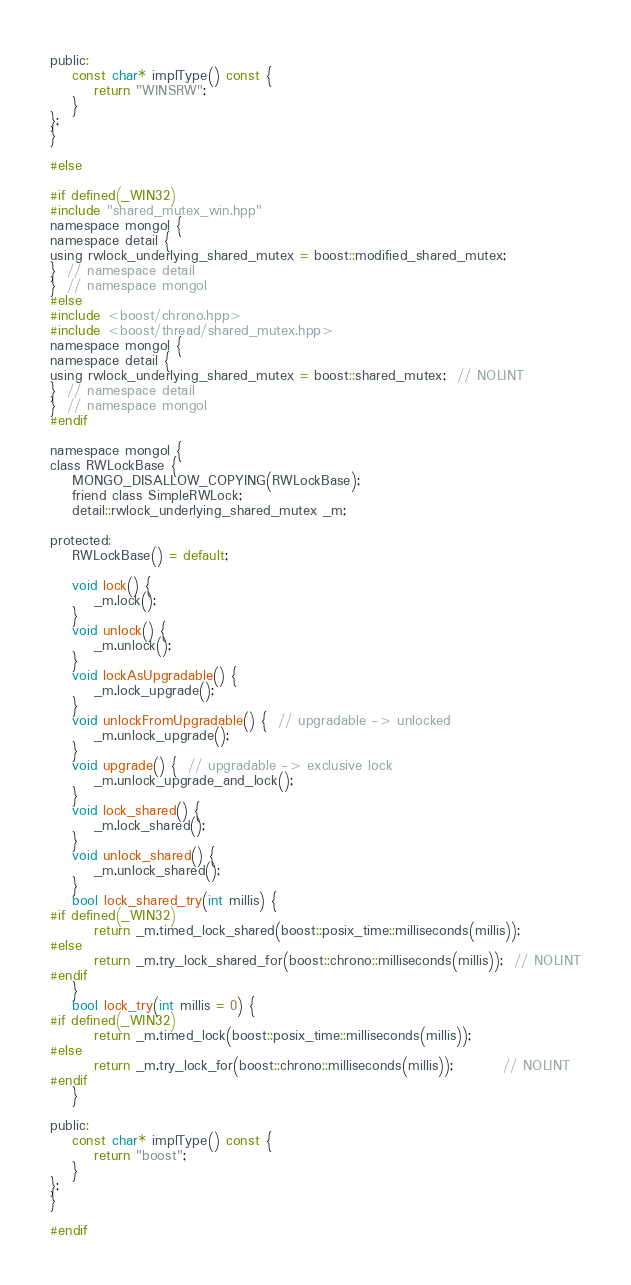<code> <loc_0><loc_0><loc_500><loc_500><_C_>public:
    const char* implType() const {
        return "WINSRW";
    }
};
}

#else

#if defined(_WIN32)
#include "shared_mutex_win.hpp"
namespace mongol {
namespace detail {
using rwlock_underlying_shared_mutex = boost::modified_shared_mutex;
}  // namespace detail
}  // namespace mongol
#else
#include <boost/chrono.hpp>
#include <boost/thread/shared_mutex.hpp>
namespace mongol {
namespace detail {
using rwlock_underlying_shared_mutex = boost::shared_mutex;  // NOLINT
}  // namespace detail
}  // namespace mongol
#endif

namespace mongol {
class RWLockBase {
    MONGO_DISALLOW_COPYING(RWLockBase);
    friend class SimpleRWLock;
    detail::rwlock_underlying_shared_mutex _m;

protected:
    RWLockBase() = default;

    void lock() {
        _m.lock();
    }
    void unlock() {
        _m.unlock();
    }
    void lockAsUpgradable() {
        _m.lock_upgrade();
    }
    void unlockFromUpgradable() {  // upgradable -> unlocked
        _m.unlock_upgrade();
    }
    void upgrade() {  // upgradable -> exclusive lock
        _m.unlock_upgrade_and_lock();
    }
    void lock_shared() {
        _m.lock_shared();
    }
    void unlock_shared() {
        _m.unlock_shared();
    }
    bool lock_shared_try(int millis) {
#if defined(_WIN32)
        return _m.timed_lock_shared(boost::posix_time::milliseconds(millis));
#else
        return _m.try_lock_shared_for(boost::chrono::milliseconds(millis));  // NOLINT
#endif
    }
    bool lock_try(int millis = 0) {
#if defined(_WIN32)
        return _m.timed_lock(boost::posix_time::milliseconds(millis));
#else
        return _m.try_lock_for(boost::chrono::milliseconds(millis));         // NOLINT
#endif
    }

public:
    const char* implType() const {
        return "boost";
    }
};
}

#endif
</code> 